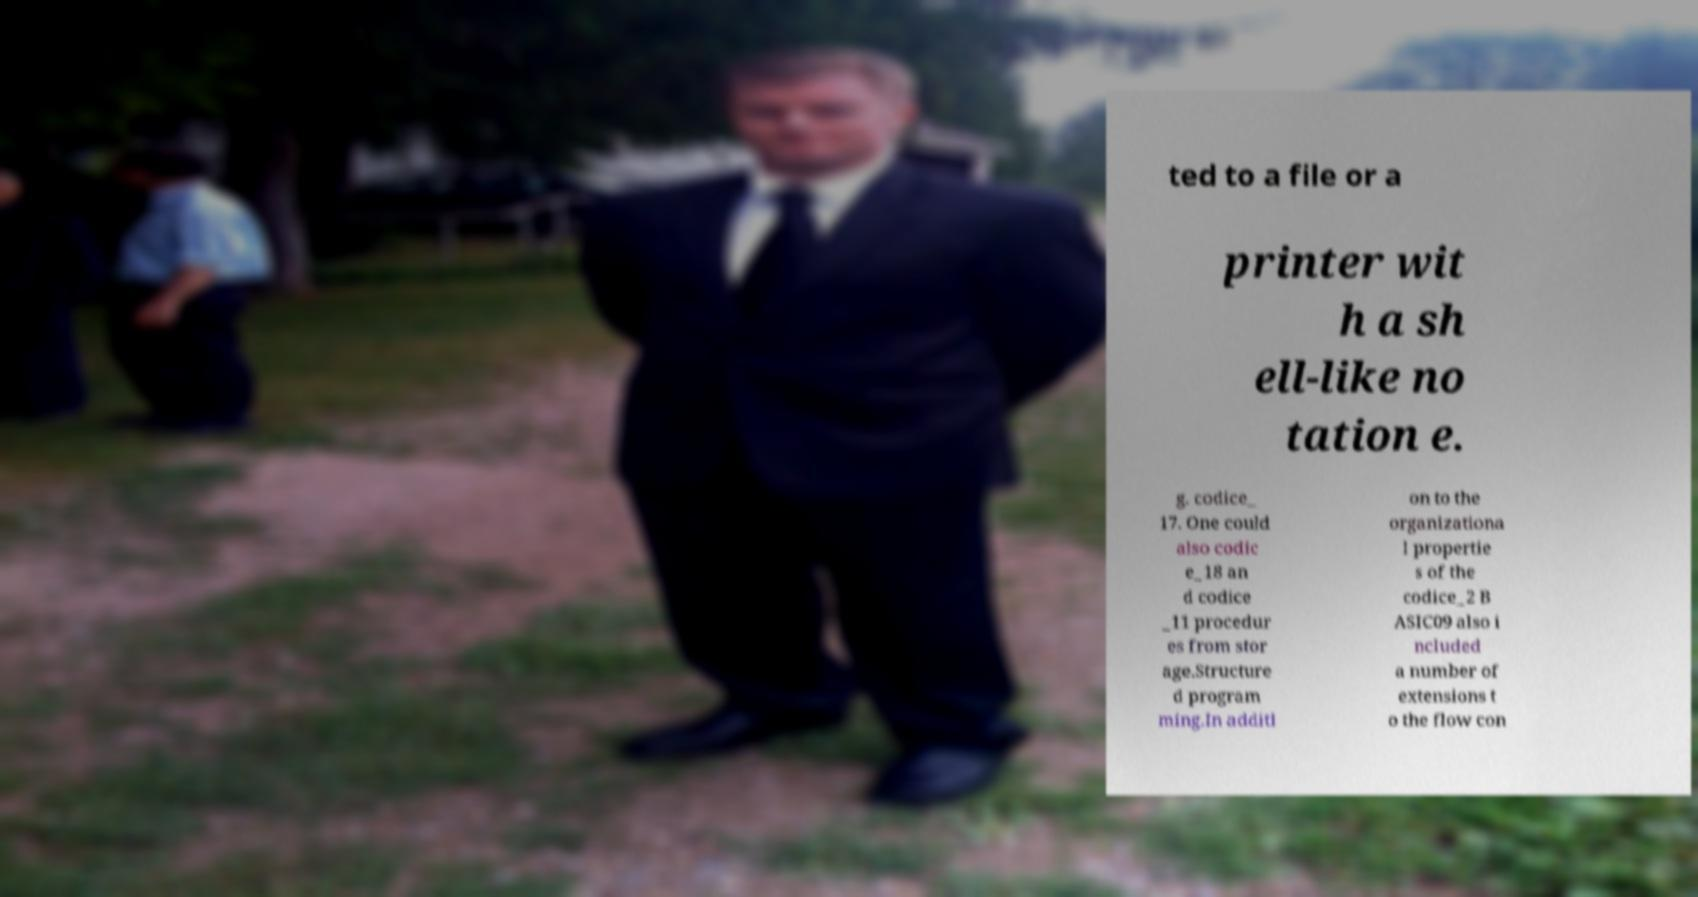What messages or text are displayed in this image? I need them in a readable, typed format. ted to a file or a printer wit h a sh ell-like no tation e. g. codice_ 17. One could also codic e_18 an d codice _11 procedur es from stor age.Structure d program ming.In additi on to the organizationa l propertie s of the codice_2 B ASIC09 also i ncluded a number of extensions t o the flow con 